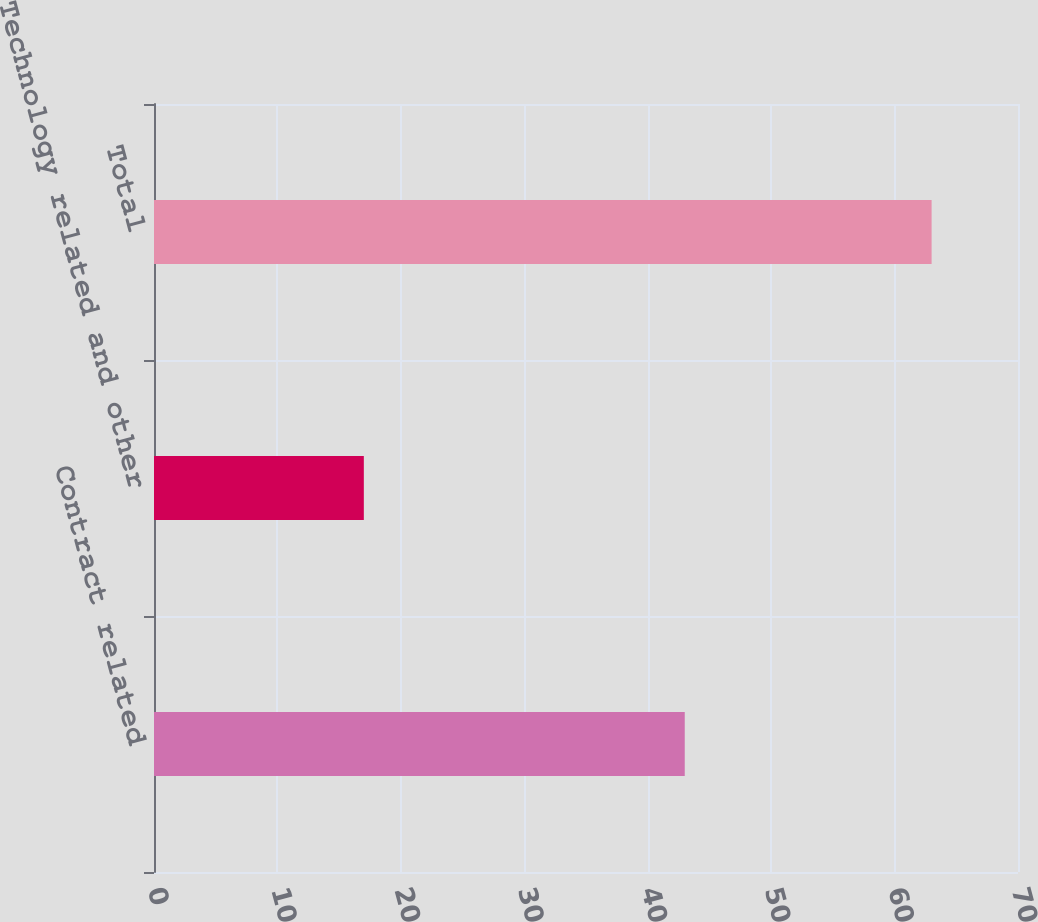Convert chart. <chart><loc_0><loc_0><loc_500><loc_500><bar_chart><fcel>Contract related<fcel>Technology related and other<fcel>Total<nl><fcel>43<fcel>17<fcel>63<nl></chart> 